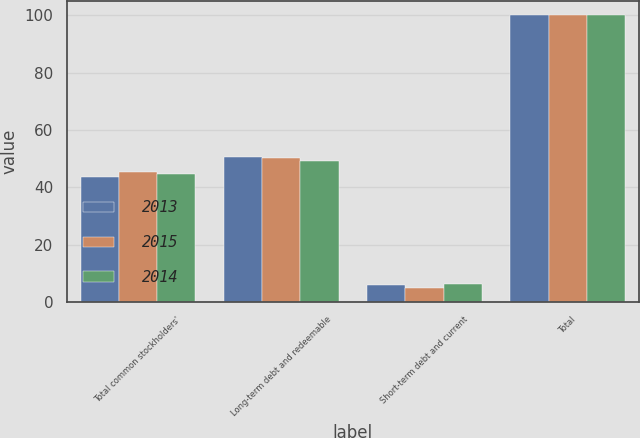Convert chart. <chart><loc_0><loc_0><loc_500><loc_500><stacked_bar_chart><ecel><fcel>Total common stockholders'<fcel>Long-term debt and redeemable<fcel>Short-term debt and current<fcel>Total<nl><fcel>2013<fcel>43.5<fcel>50.6<fcel>5.9<fcel>100<nl><fcel>2015<fcel>45.2<fcel>50.1<fcel>4.7<fcel>100<nl><fcel>2014<fcel>44.6<fcel>49.3<fcel>6.1<fcel>100<nl></chart> 